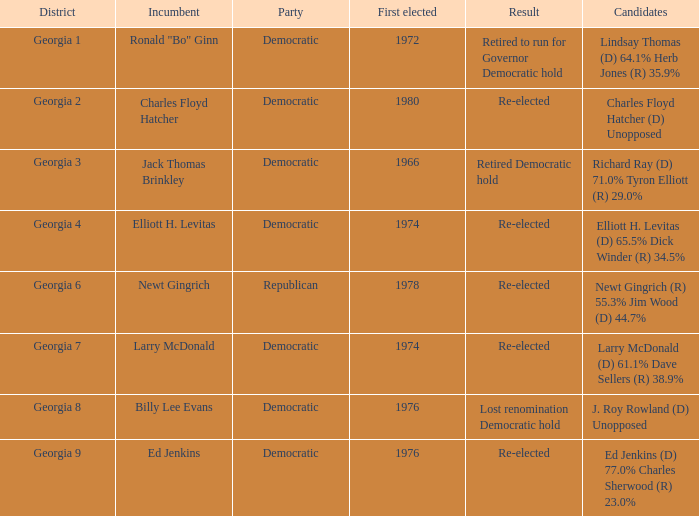In which district can larry mcdonald be found? Georgia 7. 